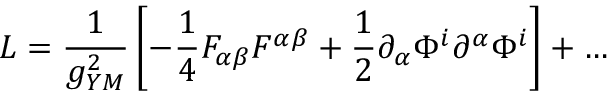Convert formula to latex. <formula><loc_0><loc_0><loc_500><loc_500>L = \frac { 1 } { g _ { Y M } ^ { 2 } } \left [ - \frac { 1 } { 4 } F _ { \alpha \beta } F ^ { \alpha \beta } + \frac { 1 } { 2 } \partial _ { \alpha } \Phi ^ { i } \partial ^ { \alpha } \Phi ^ { i } \right ] + \dots</formula> 